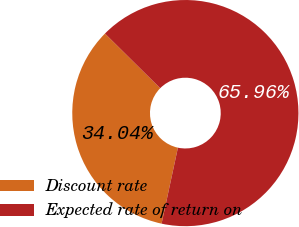Convert chart to OTSL. <chart><loc_0><loc_0><loc_500><loc_500><pie_chart><fcel>Discount rate<fcel>Expected rate of return on<nl><fcel>34.04%<fcel>65.96%<nl></chart> 